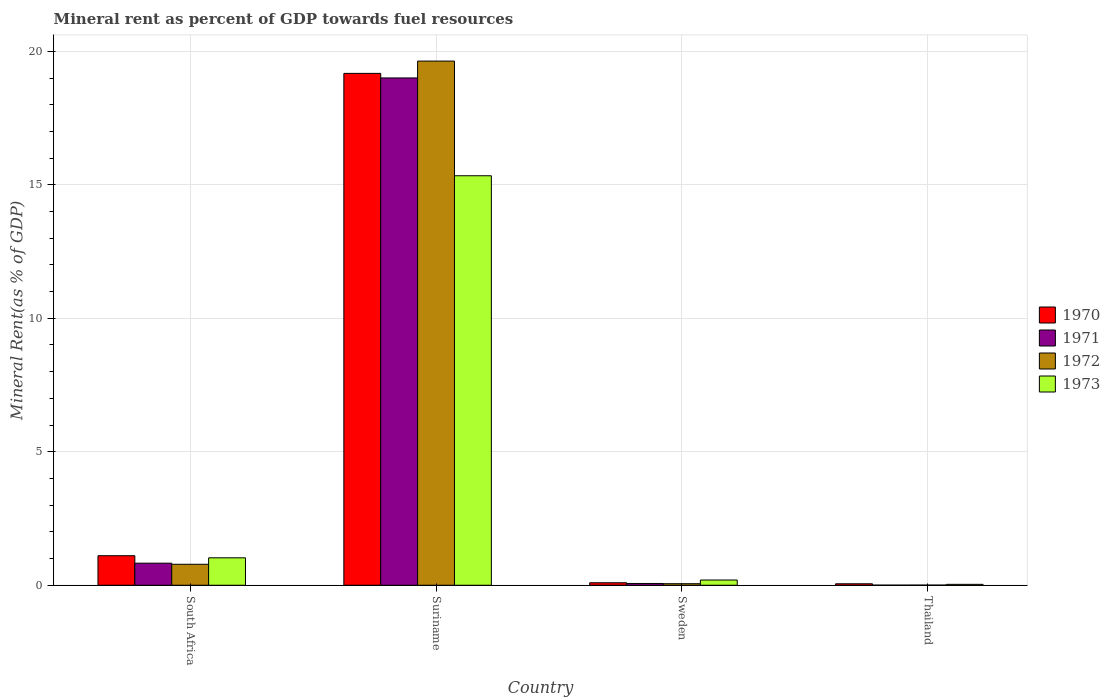How many different coloured bars are there?
Ensure brevity in your answer.  4. How many groups of bars are there?
Provide a succinct answer. 4. Are the number of bars per tick equal to the number of legend labels?
Give a very brief answer. Yes. What is the label of the 3rd group of bars from the left?
Your answer should be compact. Sweden. What is the mineral rent in 1971 in Suriname?
Offer a very short reply. 19. Across all countries, what is the maximum mineral rent in 1973?
Keep it short and to the point. 15.34. Across all countries, what is the minimum mineral rent in 1971?
Ensure brevity in your answer.  0. In which country was the mineral rent in 1972 maximum?
Your response must be concise. Suriname. In which country was the mineral rent in 1971 minimum?
Offer a terse response. Thailand. What is the total mineral rent in 1970 in the graph?
Your answer should be very brief. 20.43. What is the difference between the mineral rent in 1971 in South Africa and that in Sweden?
Your answer should be very brief. 0.76. What is the difference between the mineral rent in 1973 in Sweden and the mineral rent in 1971 in Thailand?
Make the answer very short. 0.19. What is the average mineral rent in 1973 per country?
Your answer should be compact. 4.15. What is the difference between the mineral rent of/in 1973 and mineral rent of/in 1972 in Suriname?
Offer a terse response. -4.3. In how many countries, is the mineral rent in 1973 greater than 1 %?
Your response must be concise. 2. What is the ratio of the mineral rent in 1973 in Sweden to that in Thailand?
Provide a succinct answer. 5.9. Is the mineral rent in 1970 in Sweden less than that in Thailand?
Offer a very short reply. No. Is the difference between the mineral rent in 1973 in Suriname and Sweden greater than the difference between the mineral rent in 1972 in Suriname and Sweden?
Ensure brevity in your answer.  No. What is the difference between the highest and the second highest mineral rent in 1970?
Offer a very short reply. -1.01. What is the difference between the highest and the lowest mineral rent in 1970?
Your response must be concise. 19.12. Is it the case that in every country, the sum of the mineral rent in 1972 and mineral rent in 1970 is greater than the sum of mineral rent in 1971 and mineral rent in 1973?
Provide a short and direct response. No. What does the 4th bar from the left in Thailand represents?
Provide a succinct answer. 1973. Are all the bars in the graph horizontal?
Provide a short and direct response. No. How many countries are there in the graph?
Make the answer very short. 4. What is the difference between two consecutive major ticks on the Y-axis?
Your response must be concise. 5. Does the graph contain grids?
Your answer should be compact. Yes. How many legend labels are there?
Your response must be concise. 4. What is the title of the graph?
Ensure brevity in your answer.  Mineral rent as percent of GDP towards fuel resources. Does "1966" appear as one of the legend labels in the graph?
Make the answer very short. No. What is the label or title of the Y-axis?
Keep it short and to the point. Mineral Rent(as % of GDP). What is the Mineral Rent(as % of GDP) of 1970 in South Africa?
Provide a short and direct response. 1.11. What is the Mineral Rent(as % of GDP) in 1971 in South Africa?
Offer a terse response. 0.83. What is the Mineral Rent(as % of GDP) in 1972 in South Africa?
Your answer should be very brief. 0.79. What is the Mineral Rent(as % of GDP) in 1973 in South Africa?
Provide a short and direct response. 1.03. What is the Mineral Rent(as % of GDP) of 1970 in Suriname?
Provide a short and direct response. 19.17. What is the Mineral Rent(as % of GDP) in 1971 in Suriname?
Your answer should be very brief. 19. What is the Mineral Rent(as % of GDP) of 1972 in Suriname?
Your answer should be compact. 19.63. What is the Mineral Rent(as % of GDP) in 1973 in Suriname?
Give a very brief answer. 15.34. What is the Mineral Rent(as % of GDP) in 1970 in Sweden?
Provide a succinct answer. 0.09. What is the Mineral Rent(as % of GDP) in 1971 in Sweden?
Your response must be concise. 0.07. What is the Mineral Rent(as % of GDP) in 1972 in Sweden?
Ensure brevity in your answer.  0.06. What is the Mineral Rent(as % of GDP) of 1973 in Sweden?
Offer a very short reply. 0.2. What is the Mineral Rent(as % of GDP) in 1970 in Thailand?
Ensure brevity in your answer.  0.05. What is the Mineral Rent(as % of GDP) in 1971 in Thailand?
Make the answer very short. 0. What is the Mineral Rent(as % of GDP) of 1972 in Thailand?
Your answer should be compact. 0.01. What is the Mineral Rent(as % of GDP) in 1973 in Thailand?
Keep it short and to the point. 0.03. Across all countries, what is the maximum Mineral Rent(as % of GDP) of 1970?
Your answer should be compact. 19.17. Across all countries, what is the maximum Mineral Rent(as % of GDP) of 1971?
Make the answer very short. 19. Across all countries, what is the maximum Mineral Rent(as % of GDP) in 1972?
Offer a terse response. 19.63. Across all countries, what is the maximum Mineral Rent(as % of GDP) of 1973?
Your answer should be compact. 15.34. Across all countries, what is the minimum Mineral Rent(as % of GDP) in 1970?
Provide a short and direct response. 0.05. Across all countries, what is the minimum Mineral Rent(as % of GDP) in 1971?
Provide a short and direct response. 0. Across all countries, what is the minimum Mineral Rent(as % of GDP) in 1972?
Keep it short and to the point. 0.01. Across all countries, what is the minimum Mineral Rent(as % of GDP) in 1973?
Your answer should be very brief. 0.03. What is the total Mineral Rent(as % of GDP) of 1970 in the graph?
Your response must be concise. 20.43. What is the total Mineral Rent(as % of GDP) in 1971 in the graph?
Your answer should be compact. 19.9. What is the total Mineral Rent(as % of GDP) in 1972 in the graph?
Ensure brevity in your answer.  20.48. What is the total Mineral Rent(as % of GDP) in 1973 in the graph?
Your answer should be very brief. 16.59. What is the difference between the Mineral Rent(as % of GDP) in 1970 in South Africa and that in Suriname?
Make the answer very short. -18.07. What is the difference between the Mineral Rent(as % of GDP) in 1971 in South Africa and that in Suriname?
Provide a succinct answer. -18.18. What is the difference between the Mineral Rent(as % of GDP) in 1972 in South Africa and that in Suriname?
Offer a terse response. -18.85. What is the difference between the Mineral Rent(as % of GDP) of 1973 in South Africa and that in Suriname?
Provide a short and direct response. -14.31. What is the difference between the Mineral Rent(as % of GDP) of 1970 in South Africa and that in Sweden?
Make the answer very short. 1.01. What is the difference between the Mineral Rent(as % of GDP) in 1971 in South Africa and that in Sweden?
Provide a short and direct response. 0.76. What is the difference between the Mineral Rent(as % of GDP) of 1972 in South Africa and that in Sweden?
Your answer should be compact. 0.73. What is the difference between the Mineral Rent(as % of GDP) of 1973 in South Africa and that in Sweden?
Ensure brevity in your answer.  0.83. What is the difference between the Mineral Rent(as % of GDP) in 1970 in South Africa and that in Thailand?
Your answer should be very brief. 1.05. What is the difference between the Mineral Rent(as % of GDP) of 1971 in South Africa and that in Thailand?
Your response must be concise. 0.82. What is the difference between the Mineral Rent(as % of GDP) of 1972 in South Africa and that in Thailand?
Ensure brevity in your answer.  0.78. What is the difference between the Mineral Rent(as % of GDP) of 1973 in South Africa and that in Thailand?
Keep it short and to the point. 0.99. What is the difference between the Mineral Rent(as % of GDP) in 1970 in Suriname and that in Sweden?
Make the answer very short. 19.08. What is the difference between the Mineral Rent(as % of GDP) of 1971 in Suriname and that in Sweden?
Your answer should be very brief. 18.94. What is the difference between the Mineral Rent(as % of GDP) in 1972 in Suriname and that in Sweden?
Ensure brevity in your answer.  19.58. What is the difference between the Mineral Rent(as % of GDP) of 1973 in Suriname and that in Sweden?
Offer a terse response. 15.14. What is the difference between the Mineral Rent(as % of GDP) in 1970 in Suriname and that in Thailand?
Offer a very short reply. 19.12. What is the difference between the Mineral Rent(as % of GDP) of 1971 in Suriname and that in Thailand?
Your answer should be compact. 19. What is the difference between the Mineral Rent(as % of GDP) of 1972 in Suriname and that in Thailand?
Give a very brief answer. 19.63. What is the difference between the Mineral Rent(as % of GDP) of 1973 in Suriname and that in Thailand?
Your response must be concise. 15.31. What is the difference between the Mineral Rent(as % of GDP) in 1970 in Sweden and that in Thailand?
Your answer should be compact. 0.04. What is the difference between the Mineral Rent(as % of GDP) of 1971 in Sweden and that in Thailand?
Your answer should be compact. 0.06. What is the difference between the Mineral Rent(as % of GDP) in 1972 in Sweden and that in Thailand?
Keep it short and to the point. 0.05. What is the difference between the Mineral Rent(as % of GDP) in 1973 in Sweden and that in Thailand?
Make the answer very short. 0.16. What is the difference between the Mineral Rent(as % of GDP) in 1970 in South Africa and the Mineral Rent(as % of GDP) in 1971 in Suriname?
Your response must be concise. -17.9. What is the difference between the Mineral Rent(as % of GDP) of 1970 in South Africa and the Mineral Rent(as % of GDP) of 1972 in Suriname?
Make the answer very short. -18.53. What is the difference between the Mineral Rent(as % of GDP) in 1970 in South Africa and the Mineral Rent(as % of GDP) in 1973 in Suriname?
Offer a very short reply. -14.23. What is the difference between the Mineral Rent(as % of GDP) in 1971 in South Africa and the Mineral Rent(as % of GDP) in 1972 in Suriname?
Ensure brevity in your answer.  -18.81. What is the difference between the Mineral Rent(as % of GDP) in 1971 in South Africa and the Mineral Rent(as % of GDP) in 1973 in Suriname?
Keep it short and to the point. -14.51. What is the difference between the Mineral Rent(as % of GDP) of 1972 in South Africa and the Mineral Rent(as % of GDP) of 1973 in Suriname?
Your answer should be compact. -14.55. What is the difference between the Mineral Rent(as % of GDP) in 1970 in South Africa and the Mineral Rent(as % of GDP) in 1971 in Sweden?
Your response must be concise. 1.04. What is the difference between the Mineral Rent(as % of GDP) in 1970 in South Africa and the Mineral Rent(as % of GDP) in 1972 in Sweden?
Your answer should be compact. 1.05. What is the difference between the Mineral Rent(as % of GDP) in 1970 in South Africa and the Mineral Rent(as % of GDP) in 1973 in Sweden?
Your answer should be compact. 0.91. What is the difference between the Mineral Rent(as % of GDP) of 1971 in South Africa and the Mineral Rent(as % of GDP) of 1972 in Sweden?
Make the answer very short. 0.77. What is the difference between the Mineral Rent(as % of GDP) in 1971 in South Africa and the Mineral Rent(as % of GDP) in 1973 in Sweden?
Provide a short and direct response. 0.63. What is the difference between the Mineral Rent(as % of GDP) in 1972 in South Africa and the Mineral Rent(as % of GDP) in 1973 in Sweden?
Your answer should be very brief. 0.59. What is the difference between the Mineral Rent(as % of GDP) in 1970 in South Africa and the Mineral Rent(as % of GDP) in 1971 in Thailand?
Your answer should be very brief. 1.1. What is the difference between the Mineral Rent(as % of GDP) in 1970 in South Africa and the Mineral Rent(as % of GDP) in 1972 in Thailand?
Ensure brevity in your answer.  1.1. What is the difference between the Mineral Rent(as % of GDP) of 1970 in South Africa and the Mineral Rent(as % of GDP) of 1973 in Thailand?
Keep it short and to the point. 1.07. What is the difference between the Mineral Rent(as % of GDP) of 1971 in South Africa and the Mineral Rent(as % of GDP) of 1972 in Thailand?
Give a very brief answer. 0.82. What is the difference between the Mineral Rent(as % of GDP) in 1971 in South Africa and the Mineral Rent(as % of GDP) in 1973 in Thailand?
Your answer should be compact. 0.79. What is the difference between the Mineral Rent(as % of GDP) of 1972 in South Africa and the Mineral Rent(as % of GDP) of 1973 in Thailand?
Offer a very short reply. 0.75. What is the difference between the Mineral Rent(as % of GDP) of 1970 in Suriname and the Mineral Rent(as % of GDP) of 1971 in Sweden?
Offer a terse response. 19.11. What is the difference between the Mineral Rent(as % of GDP) in 1970 in Suriname and the Mineral Rent(as % of GDP) in 1972 in Sweden?
Offer a very short reply. 19.12. What is the difference between the Mineral Rent(as % of GDP) of 1970 in Suriname and the Mineral Rent(as % of GDP) of 1973 in Sweden?
Give a very brief answer. 18.98. What is the difference between the Mineral Rent(as % of GDP) in 1971 in Suriname and the Mineral Rent(as % of GDP) in 1972 in Sweden?
Offer a very short reply. 18.95. What is the difference between the Mineral Rent(as % of GDP) of 1971 in Suriname and the Mineral Rent(as % of GDP) of 1973 in Sweden?
Your answer should be very brief. 18.81. What is the difference between the Mineral Rent(as % of GDP) in 1972 in Suriname and the Mineral Rent(as % of GDP) in 1973 in Sweden?
Offer a terse response. 19.44. What is the difference between the Mineral Rent(as % of GDP) in 1970 in Suriname and the Mineral Rent(as % of GDP) in 1971 in Thailand?
Provide a short and direct response. 19.17. What is the difference between the Mineral Rent(as % of GDP) of 1970 in Suriname and the Mineral Rent(as % of GDP) of 1972 in Thailand?
Keep it short and to the point. 19.17. What is the difference between the Mineral Rent(as % of GDP) in 1970 in Suriname and the Mineral Rent(as % of GDP) in 1973 in Thailand?
Keep it short and to the point. 19.14. What is the difference between the Mineral Rent(as % of GDP) in 1971 in Suriname and the Mineral Rent(as % of GDP) in 1972 in Thailand?
Your answer should be very brief. 19. What is the difference between the Mineral Rent(as % of GDP) of 1971 in Suriname and the Mineral Rent(as % of GDP) of 1973 in Thailand?
Give a very brief answer. 18.97. What is the difference between the Mineral Rent(as % of GDP) of 1972 in Suriname and the Mineral Rent(as % of GDP) of 1973 in Thailand?
Your answer should be very brief. 19.6. What is the difference between the Mineral Rent(as % of GDP) of 1970 in Sweden and the Mineral Rent(as % of GDP) of 1971 in Thailand?
Keep it short and to the point. 0.09. What is the difference between the Mineral Rent(as % of GDP) in 1970 in Sweden and the Mineral Rent(as % of GDP) in 1972 in Thailand?
Ensure brevity in your answer.  0.09. What is the difference between the Mineral Rent(as % of GDP) of 1970 in Sweden and the Mineral Rent(as % of GDP) of 1973 in Thailand?
Offer a terse response. 0.06. What is the difference between the Mineral Rent(as % of GDP) of 1971 in Sweden and the Mineral Rent(as % of GDP) of 1972 in Thailand?
Your answer should be compact. 0.06. What is the difference between the Mineral Rent(as % of GDP) in 1971 in Sweden and the Mineral Rent(as % of GDP) in 1973 in Thailand?
Make the answer very short. 0.03. What is the difference between the Mineral Rent(as % of GDP) of 1972 in Sweden and the Mineral Rent(as % of GDP) of 1973 in Thailand?
Your answer should be compact. 0.02. What is the average Mineral Rent(as % of GDP) of 1970 per country?
Your answer should be compact. 5.11. What is the average Mineral Rent(as % of GDP) of 1971 per country?
Provide a short and direct response. 4.97. What is the average Mineral Rent(as % of GDP) of 1972 per country?
Your answer should be compact. 5.12. What is the average Mineral Rent(as % of GDP) of 1973 per country?
Ensure brevity in your answer.  4.15. What is the difference between the Mineral Rent(as % of GDP) of 1970 and Mineral Rent(as % of GDP) of 1971 in South Africa?
Provide a short and direct response. 0.28. What is the difference between the Mineral Rent(as % of GDP) of 1970 and Mineral Rent(as % of GDP) of 1972 in South Africa?
Provide a succinct answer. 0.32. What is the difference between the Mineral Rent(as % of GDP) of 1970 and Mineral Rent(as % of GDP) of 1973 in South Africa?
Offer a terse response. 0.08. What is the difference between the Mineral Rent(as % of GDP) of 1971 and Mineral Rent(as % of GDP) of 1972 in South Africa?
Your response must be concise. 0.04. What is the difference between the Mineral Rent(as % of GDP) in 1971 and Mineral Rent(as % of GDP) in 1973 in South Africa?
Offer a very short reply. -0.2. What is the difference between the Mineral Rent(as % of GDP) in 1972 and Mineral Rent(as % of GDP) in 1973 in South Africa?
Your answer should be compact. -0.24. What is the difference between the Mineral Rent(as % of GDP) in 1970 and Mineral Rent(as % of GDP) in 1971 in Suriname?
Your response must be concise. 0.17. What is the difference between the Mineral Rent(as % of GDP) of 1970 and Mineral Rent(as % of GDP) of 1972 in Suriname?
Ensure brevity in your answer.  -0.46. What is the difference between the Mineral Rent(as % of GDP) in 1970 and Mineral Rent(as % of GDP) in 1973 in Suriname?
Make the answer very short. 3.84. What is the difference between the Mineral Rent(as % of GDP) of 1971 and Mineral Rent(as % of GDP) of 1972 in Suriname?
Give a very brief answer. -0.63. What is the difference between the Mineral Rent(as % of GDP) in 1971 and Mineral Rent(as % of GDP) in 1973 in Suriname?
Offer a terse response. 3.66. What is the difference between the Mineral Rent(as % of GDP) of 1972 and Mineral Rent(as % of GDP) of 1973 in Suriname?
Offer a very short reply. 4.3. What is the difference between the Mineral Rent(as % of GDP) of 1970 and Mineral Rent(as % of GDP) of 1971 in Sweden?
Your answer should be very brief. 0.03. What is the difference between the Mineral Rent(as % of GDP) in 1970 and Mineral Rent(as % of GDP) in 1972 in Sweden?
Give a very brief answer. 0.04. What is the difference between the Mineral Rent(as % of GDP) of 1970 and Mineral Rent(as % of GDP) of 1973 in Sweden?
Make the answer very short. -0.1. What is the difference between the Mineral Rent(as % of GDP) in 1971 and Mineral Rent(as % of GDP) in 1972 in Sweden?
Your answer should be very brief. 0.01. What is the difference between the Mineral Rent(as % of GDP) in 1971 and Mineral Rent(as % of GDP) in 1973 in Sweden?
Offer a terse response. -0.13. What is the difference between the Mineral Rent(as % of GDP) of 1972 and Mineral Rent(as % of GDP) of 1973 in Sweden?
Make the answer very short. -0.14. What is the difference between the Mineral Rent(as % of GDP) in 1970 and Mineral Rent(as % of GDP) in 1971 in Thailand?
Offer a terse response. 0.05. What is the difference between the Mineral Rent(as % of GDP) in 1970 and Mineral Rent(as % of GDP) in 1972 in Thailand?
Offer a very short reply. 0.05. What is the difference between the Mineral Rent(as % of GDP) in 1970 and Mineral Rent(as % of GDP) in 1973 in Thailand?
Your answer should be compact. 0.02. What is the difference between the Mineral Rent(as % of GDP) of 1971 and Mineral Rent(as % of GDP) of 1972 in Thailand?
Your answer should be very brief. -0. What is the difference between the Mineral Rent(as % of GDP) of 1971 and Mineral Rent(as % of GDP) of 1973 in Thailand?
Provide a succinct answer. -0.03. What is the difference between the Mineral Rent(as % of GDP) in 1972 and Mineral Rent(as % of GDP) in 1973 in Thailand?
Your answer should be compact. -0.03. What is the ratio of the Mineral Rent(as % of GDP) in 1970 in South Africa to that in Suriname?
Your answer should be very brief. 0.06. What is the ratio of the Mineral Rent(as % of GDP) in 1971 in South Africa to that in Suriname?
Provide a short and direct response. 0.04. What is the ratio of the Mineral Rent(as % of GDP) in 1972 in South Africa to that in Suriname?
Your response must be concise. 0.04. What is the ratio of the Mineral Rent(as % of GDP) of 1973 in South Africa to that in Suriname?
Make the answer very short. 0.07. What is the ratio of the Mineral Rent(as % of GDP) in 1970 in South Africa to that in Sweden?
Your answer should be compact. 11.94. What is the ratio of the Mineral Rent(as % of GDP) in 1971 in South Africa to that in Sweden?
Your answer should be very brief. 12.48. What is the ratio of the Mineral Rent(as % of GDP) of 1972 in South Africa to that in Sweden?
Your response must be concise. 13.67. What is the ratio of the Mineral Rent(as % of GDP) in 1973 in South Africa to that in Sweden?
Your answer should be compact. 5.26. What is the ratio of the Mineral Rent(as % of GDP) in 1970 in South Africa to that in Thailand?
Provide a short and direct response. 20.48. What is the ratio of the Mineral Rent(as % of GDP) in 1971 in South Africa to that in Thailand?
Keep it short and to the point. 258.3. What is the ratio of the Mineral Rent(as % of GDP) of 1972 in South Africa to that in Thailand?
Provide a short and direct response. 154.88. What is the ratio of the Mineral Rent(as % of GDP) in 1973 in South Africa to that in Thailand?
Offer a terse response. 31.01. What is the ratio of the Mineral Rent(as % of GDP) in 1970 in Suriname to that in Sweden?
Provide a succinct answer. 207. What is the ratio of the Mineral Rent(as % of GDP) in 1971 in Suriname to that in Sweden?
Ensure brevity in your answer.  287. What is the ratio of the Mineral Rent(as % of GDP) in 1972 in Suriname to that in Sweden?
Keep it short and to the point. 341.94. What is the ratio of the Mineral Rent(as % of GDP) in 1973 in Suriname to that in Sweden?
Offer a terse response. 78.52. What is the ratio of the Mineral Rent(as % of GDP) in 1970 in Suriname to that in Thailand?
Your answer should be very brief. 355.06. What is the ratio of the Mineral Rent(as % of GDP) in 1971 in Suriname to that in Thailand?
Offer a terse response. 5940.64. What is the ratio of the Mineral Rent(as % of GDP) of 1972 in Suriname to that in Thailand?
Your answer should be very brief. 3873.35. What is the ratio of the Mineral Rent(as % of GDP) of 1973 in Suriname to that in Thailand?
Your answer should be compact. 463.15. What is the ratio of the Mineral Rent(as % of GDP) of 1970 in Sweden to that in Thailand?
Make the answer very short. 1.72. What is the ratio of the Mineral Rent(as % of GDP) in 1971 in Sweden to that in Thailand?
Provide a succinct answer. 20.7. What is the ratio of the Mineral Rent(as % of GDP) of 1972 in Sweden to that in Thailand?
Provide a succinct answer. 11.33. What is the ratio of the Mineral Rent(as % of GDP) of 1973 in Sweden to that in Thailand?
Offer a very short reply. 5.9. What is the difference between the highest and the second highest Mineral Rent(as % of GDP) in 1970?
Offer a very short reply. 18.07. What is the difference between the highest and the second highest Mineral Rent(as % of GDP) in 1971?
Ensure brevity in your answer.  18.18. What is the difference between the highest and the second highest Mineral Rent(as % of GDP) of 1972?
Your answer should be compact. 18.85. What is the difference between the highest and the second highest Mineral Rent(as % of GDP) of 1973?
Make the answer very short. 14.31. What is the difference between the highest and the lowest Mineral Rent(as % of GDP) of 1970?
Give a very brief answer. 19.12. What is the difference between the highest and the lowest Mineral Rent(as % of GDP) of 1971?
Provide a succinct answer. 19. What is the difference between the highest and the lowest Mineral Rent(as % of GDP) in 1972?
Ensure brevity in your answer.  19.63. What is the difference between the highest and the lowest Mineral Rent(as % of GDP) of 1973?
Offer a very short reply. 15.31. 